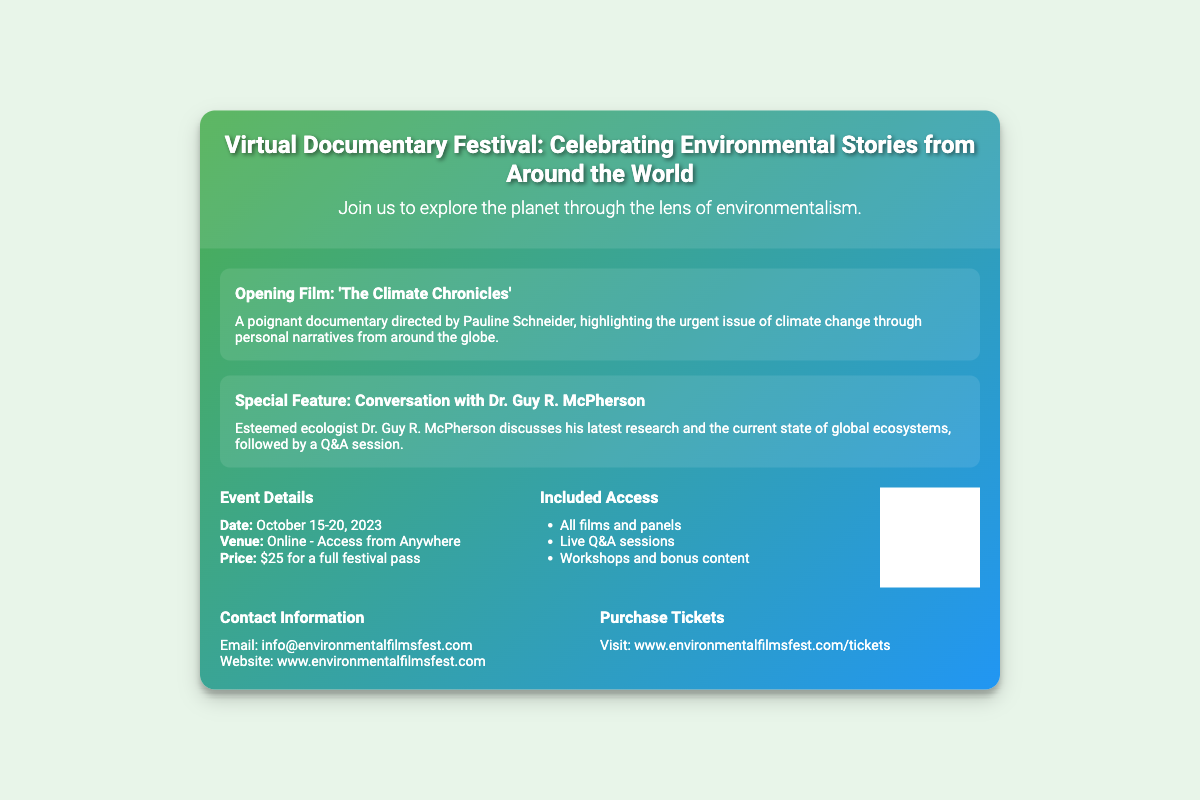what is the title of the opening film? The title of the opening film is mentioned in the highlight section of the document.
Answer: The Climate Chronicles who directed the opening film? The document specifies the director of the opening film in the highlighted description.
Answer: Pauline Schneider what are the dates of the festival? The dates of the event are provided in the Event Details section of the document.
Answer: October 15-20, 2023 how much does a full festival pass cost? The document includes the price of the festival pass in the Event Details section.
Answer: $25 what is the venue for the festival? The venue is indicated as an online event in the Event Details section.
Answer: Online - Access from Anywhere who is participating in the special feature conversation? The special feature conversation participant is mentioned in the highlighted section.
Answer: Dr. Guy R. McPherson what type of access is included with the ticket? The document lists the included access items in the Included Access section.
Answer: All films and panels how can you purchase tickets? The method for purchasing tickets is found in the Purchase Tickets section of the document.
Answer: Visit: www.environmentalfilmsfest.com/tickets what is the email address for contact information? The document includes the contact information in the Contact Information section.
Answer: info@environmentalfilmsfest.com 